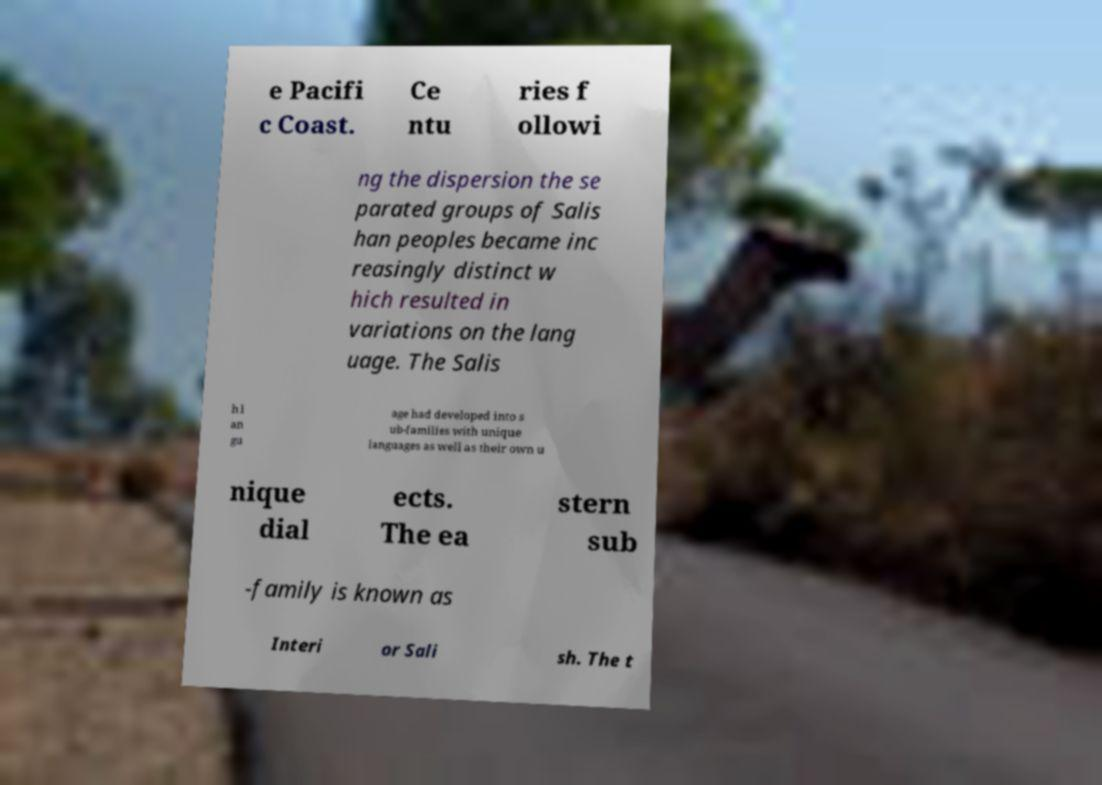I need the written content from this picture converted into text. Can you do that? e Pacifi c Coast. Ce ntu ries f ollowi ng the dispersion the se parated groups of Salis han peoples became inc reasingly distinct w hich resulted in variations on the lang uage. The Salis h l an gu age had developed into s ub-families with unique languages as well as their own u nique dial ects. The ea stern sub -family is known as Interi or Sali sh. The t 